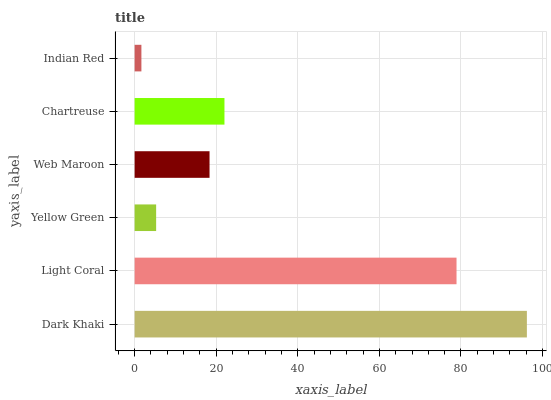Is Indian Red the minimum?
Answer yes or no. Yes. Is Dark Khaki the maximum?
Answer yes or no. Yes. Is Light Coral the minimum?
Answer yes or no. No. Is Light Coral the maximum?
Answer yes or no. No. Is Dark Khaki greater than Light Coral?
Answer yes or no. Yes. Is Light Coral less than Dark Khaki?
Answer yes or no. Yes. Is Light Coral greater than Dark Khaki?
Answer yes or no. No. Is Dark Khaki less than Light Coral?
Answer yes or no. No. Is Chartreuse the high median?
Answer yes or no. Yes. Is Web Maroon the low median?
Answer yes or no. Yes. Is Light Coral the high median?
Answer yes or no. No. Is Indian Red the low median?
Answer yes or no. No. 